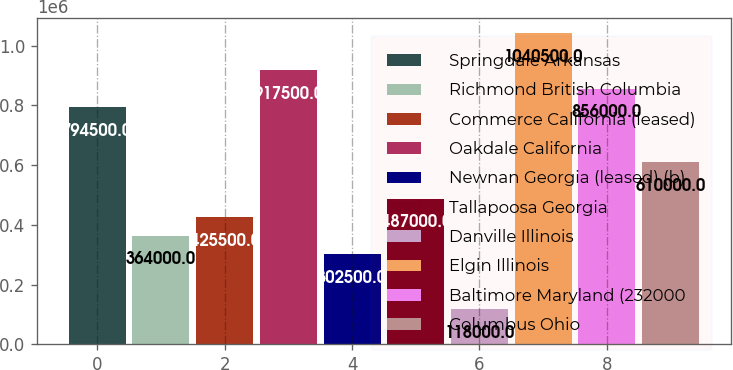<chart> <loc_0><loc_0><loc_500><loc_500><bar_chart><fcel>Springdale Arkansas<fcel>Richmond British Columbia<fcel>Commerce California (leased)<fcel>Oakdale California<fcel>Newnan Georgia (leased) (b)<fcel>Tallapoosa Georgia<fcel>Danville Illinois<fcel>Elgin Illinois<fcel>Baltimore Maryland (232000<fcel>Columbus Ohio<nl><fcel>794500<fcel>364000<fcel>425500<fcel>917500<fcel>302500<fcel>487000<fcel>118000<fcel>1.0405e+06<fcel>856000<fcel>610000<nl></chart> 